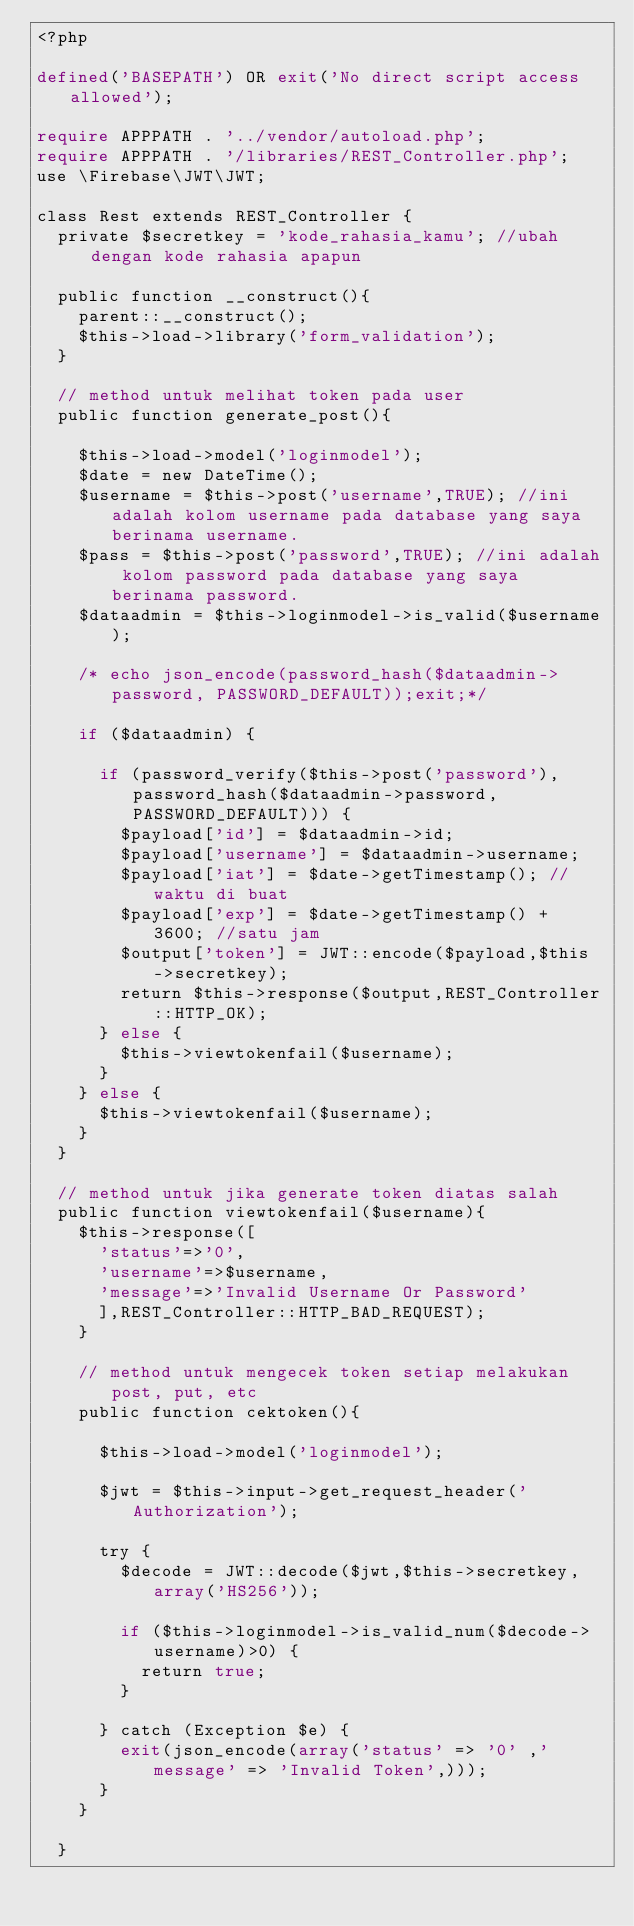<code> <loc_0><loc_0><loc_500><loc_500><_PHP_><?php

defined('BASEPATH') OR exit('No direct script access allowed');

require APPPATH . '../vendor/autoload.php';
require APPPATH . '/libraries/REST_Controller.php';
use \Firebase\JWT\JWT;

class Rest extends REST_Controller {
  private $secretkey = 'kode_rahasia_kamu'; //ubah dengan kode rahasia apapun

  public function __construct(){
    parent::__construct();
    $this->load->library('form_validation');
  }

  // method untuk melihat token pada user
  public function generate_post(){

    $this->load->model('loginmodel');
    $date = new DateTime();
    $username = $this->post('username',TRUE); //ini adalah kolom username pada database yang saya berinama username.
    $pass = $this->post('password',TRUE); //ini adalah kolom password pada database yang saya berinama password.
    $dataadmin = $this->loginmodel->is_valid($username);

    /* echo json_encode(password_hash($dataadmin->password, PASSWORD_DEFAULT));exit;*/

    if ($dataadmin) {

      if (password_verify($this->post('password'),password_hash($dataadmin->password, PASSWORD_DEFAULT))) {
        $payload['id'] = $dataadmin->id;
        $payload['username'] = $dataadmin->username;
        $payload['iat'] = $date->getTimestamp(); //waktu di buat
        $payload['exp'] = $date->getTimestamp() + 3600; //satu jam
        $output['token'] = JWT::encode($payload,$this->secretkey);
        return $this->response($output,REST_Controller::HTTP_OK);
      } else {
        $this->viewtokenfail($username);
      }
    } else {
      $this->viewtokenfail($username);
    }
  }

  // method untuk jika generate token diatas salah
  public function viewtokenfail($username){
    $this->response([
      'status'=>'0',
      'username'=>$username,
      'message'=>'Invalid Username Or Password'
      ],REST_Controller::HTTP_BAD_REQUEST);
    }

    // method untuk mengecek token setiap melakukan post, put, etc
    public function cektoken(){

      $this->load->model('loginmodel');

      $jwt = $this->input->get_request_header('Authorization');

      try {
        $decode = JWT::decode($jwt,$this->secretkey,array('HS256'));

        if ($this->loginmodel->is_valid_num($decode->username)>0) {
          return true;
        }

      } catch (Exception $e) {
        exit(json_encode(array('status' => '0' ,'message' => 'Invalid Token',)));
      }
    }

  }
</code> 